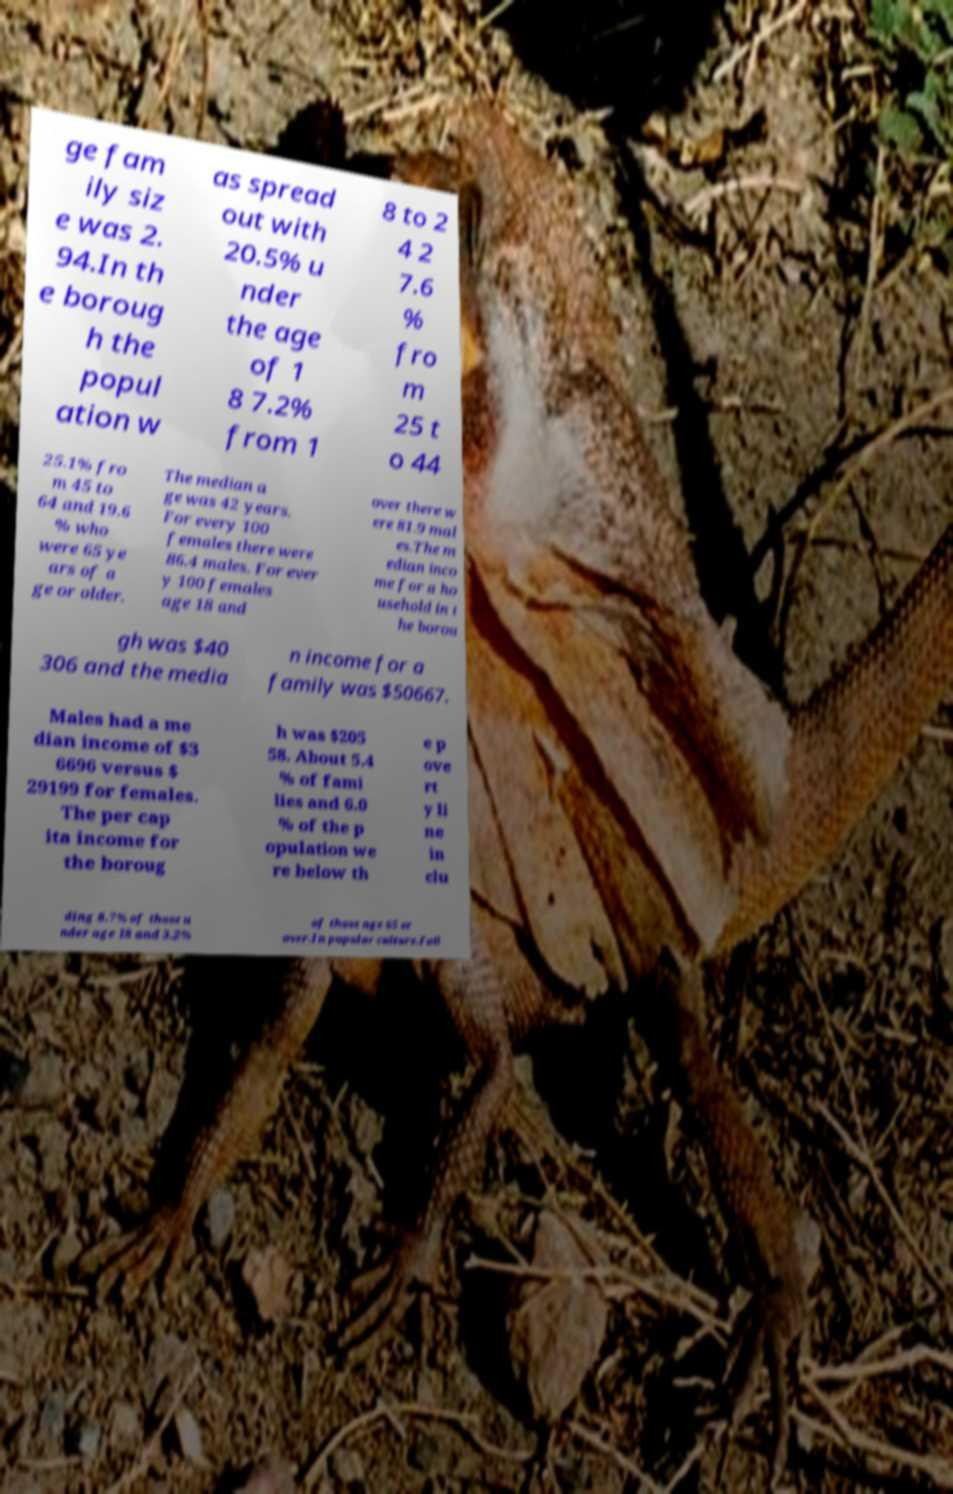Could you extract and type out the text from this image? ge fam ily siz e was 2. 94.In th e boroug h the popul ation w as spread out with 20.5% u nder the age of 1 8 7.2% from 1 8 to 2 4 2 7.6 % fro m 25 t o 44 25.1% fro m 45 to 64 and 19.6 % who were 65 ye ars of a ge or older. The median a ge was 42 years. For every 100 females there were 86.4 males. For ever y 100 females age 18 and over there w ere 81.9 mal es.The m edian inco me for a ho usehold in t he borou gh was $40 306 and the media n income for a family was $50667. Males had a me dian income of $3 6696 versus $ 29199 for females. The per cap ita income for the boroug h was $205 58. About 5.4 % of fami lies and 6.0 % of the p opulation we re below th e p ove rt y li ne in clu ding 8.7% of those u nder age 18 and 3.2% of those age 65 or over.In popular culture.Foll 